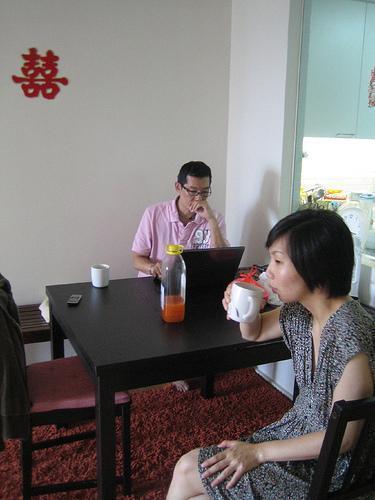Why is the woman blowing on the mug?
Answer the question by selecting the correct answer among the 4 following choices.
Options: To cool, to inflate, to move, to spin. To cool. 